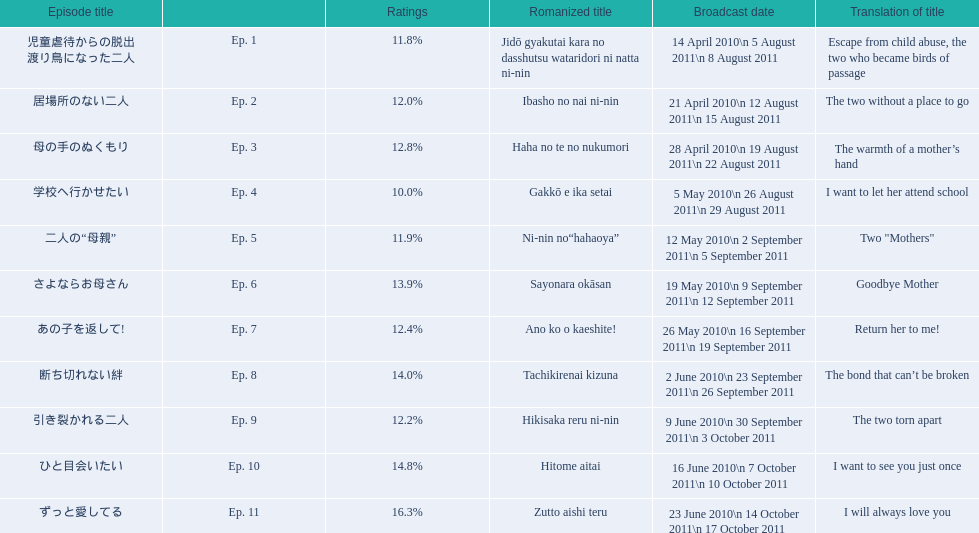What are the episode numbers? Ep. 1, Ep. 2, Ep. 3, Ep. 4, Ep. 5, Ep. 6, Ep. 7, Ep. 8, Ep. 9, Ep. 10, Ep. 11. What was the percentage of total ratings for episode 8? 14.0%. Can you parse all the data within this table? {'header': ['Episode title', '', 'Ratings', 'Romanized title', 'Broadcast date', 'Translation of title'], 'rows': [['児童虐待からの脱出 渡り鳥になった二人', 'Ep. 1', '11.8%', 'Jidō gyakutai kara no dasshutsu wataridori ni natta ni-nin', '14 April 2010\\n 5 August 2011\\n 8 August 2011', 'Escape from child abuse, the two who became birds of passage'], ['居場所のない二人', 'Ep. 2', '12.0%', 'Ibasho no nai ni-nin', '21 April 2010\\n 12 August 2011\\n 15 August 2011', 'The two without a place to go'], ['母の手のぬくもり', 'Ep. 3', '12.8%', 'Haha no te no nukumori', '28 April 2010\\n 19 August 2011\\n 22 August 2011', 'The warmth of a mother’s hand'], ['学校へ行かせたい', 'Ep. 4', '10.0%', 'Gakkō e ika setai', '5 May 2010\\n 26 August 2011\\n 29 August 2011', 'I want to let her attend school'], ['二人の“母親”', 'Ep. 5', '11.9%', 'Ni-nin no“hahaoya”', '12 May 2010\\n 2 September 2011\\n 5 September 2011', 'Two "Mothers"'], ['さよならお母さん', 'Ep. 6', '13.9%', 'Sayonara okāsan', '19 May 2010\\n 9 September 2011\\n 12 September 2011', 'Goodbye Mother'], ['あの子を返して!', 'Ep. 7', '12.4%', 'Ano ko o kaeshite!', '26 May 2010\\n 16 September 2011\\n 19 September 2011', 'Return her to me!'], ['断ち切れない絆', 'Ep. 8', '14.0%', 'Tachikirenai kizuna', '2 June 2010\\n 23 September 2011\\n 26 September 2011', 'The bond that can’t be broken'], ['引き裂かれる二人', 'Ep. 9', '12.2%', 'Hikisaka reru ni-nin', '9 June 2010\\n 30 September 2011\\n 3 October 2011', 'The two torn apart'], ['ひと目会いたい', 'Ep. 10', '14.8%', 'Hitome aitai', '16 June 2010\\n 7 October 2011\\n 10 October 2011', 'I want to see you just once'], ['ずっと愛してる', 'Ep. 11', '16.3%', 'Zutto aishi teru', '23 June 2010\\n 14 October 2011\\n 17 October 2011', 'I will always love you']]} 